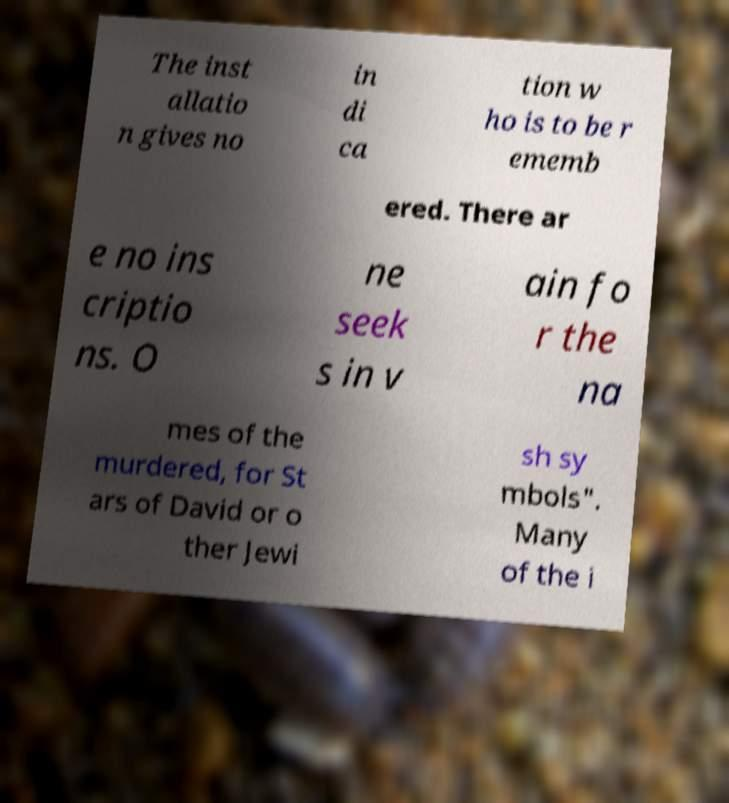Can you accurately transcribe the text from the provided image for me? The inst allatio n gives no in di ca tion w ho is to be r ememb ered. There ar e no ins criptio ns. O ne seek s in v ain fo r the na mes of the murdered, for St ars of David or o ther Jewi sh sy mbols". Many of the i 